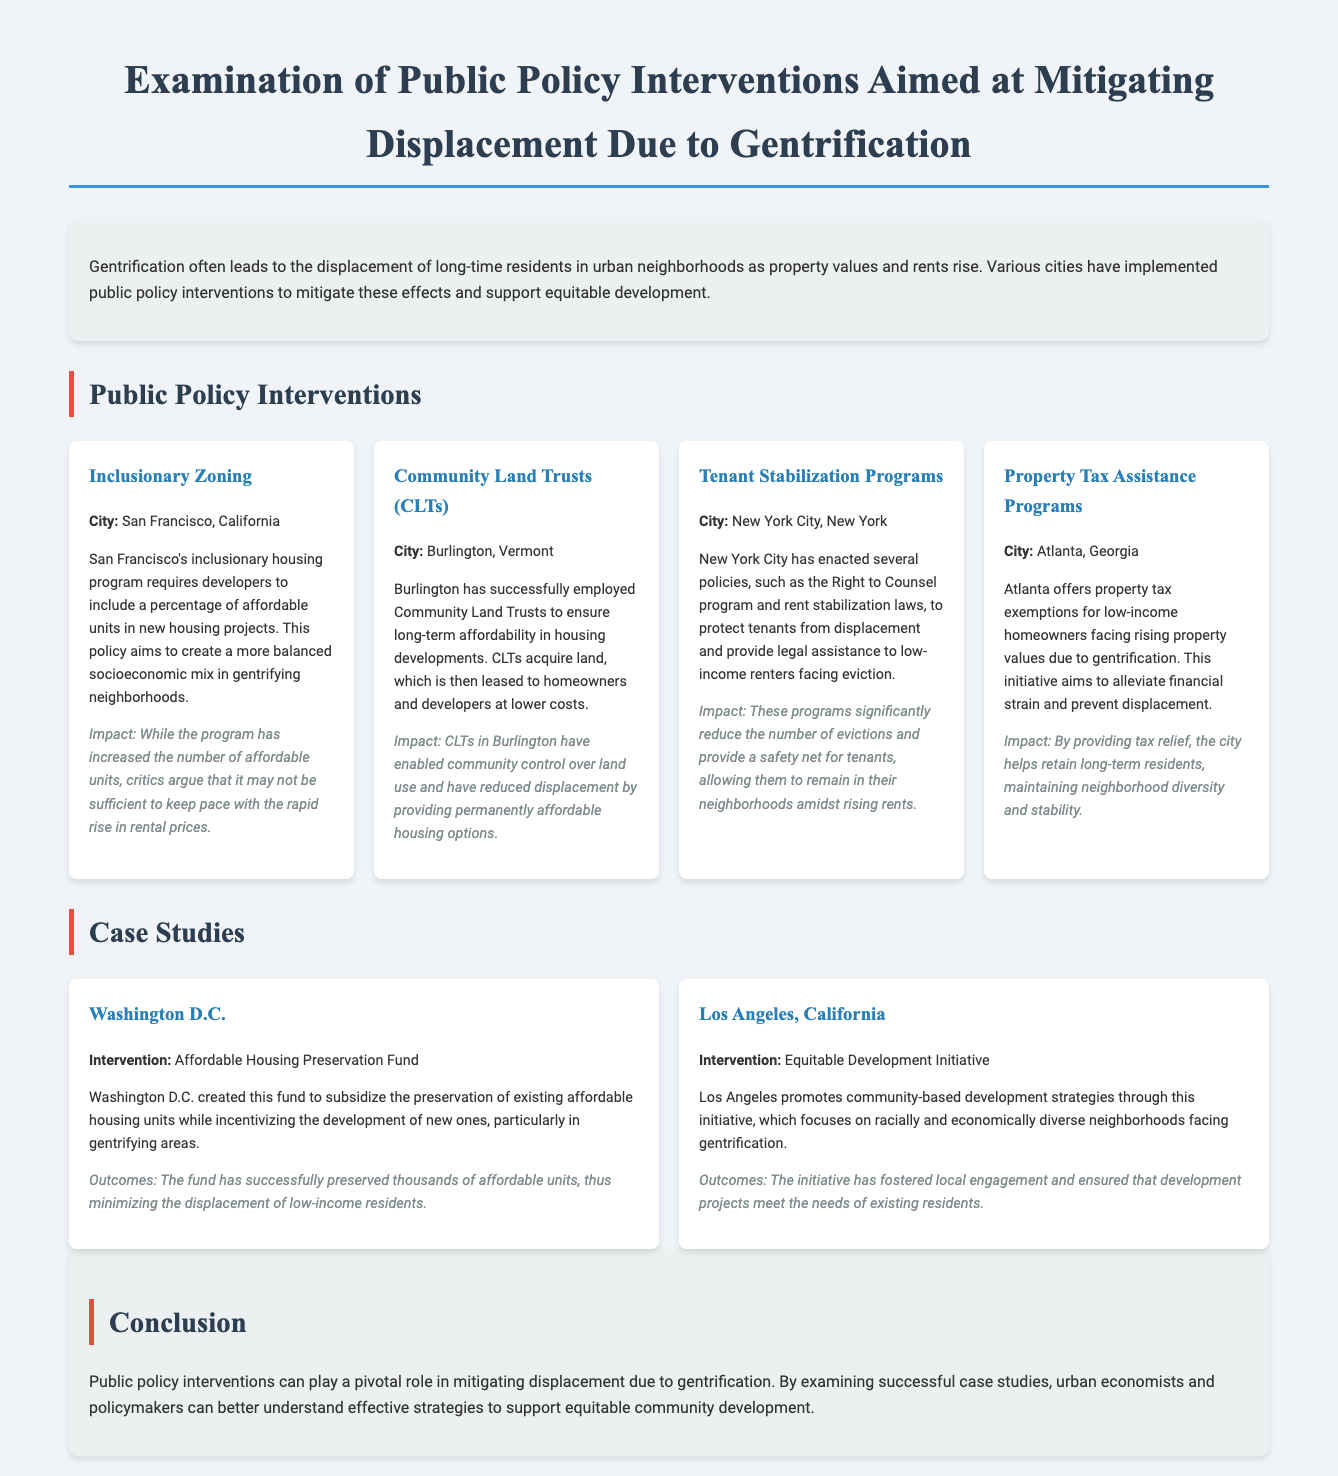What is the title of the document? The title presented at the top of the document identifies the main focus, which is related to public policy interventions to mitigate displacement due to gentrification.
Answer: Examination of Public Policy Interventions Aimed at Mitigating Displacement Due to Gentrification Which city implemented an Inclusionary Zoning policy? The specific public policy interventions are associated with cities, and Inclusionary Zoning is linked to San Francisco.
Answer: San Francisco, California What program has been enacted in New York City to protect tenants from displacement? The document lists several tenant protection measures in New York City, including notable programs among them.
Answer: Right to Counsel What is the impact of Community Land Trusts in Burlington? The document mentions the outcome of the CLTs in Burlington, focusing on their role in maintaining housing affordability and reducing displacement.
Answer: Permanently affordable housing options How many affordable units have been preserved due to Washington D.C.'s intervention? The document states the outcomes related to the Affordable Housing Preservation Fund, focusing on its success in maintaining affordable housing.
Answer: Thousands of affordable units What is the focus of the Equitable Development Initiative in Los Angeles? The initiative's aims are described in terms of promoting development strategies that cater to community needs amid gentrification pressures.
Answer: Community-based development strategies In which policy intervention does Atlanta provide property tax exemptions? The document lists specific interventions by city, and Atlanta’s policy relates directly to property tax relief for low-income homeowners.
Answer: Property Tax Assistance Programs What is a suggested outcome of the policies discussed in the document? The conclusion summarizes the purpose and anticipated results of the interventions, emphasizing their role in combating gentrification effects.
Answer: Mitigating displacement 